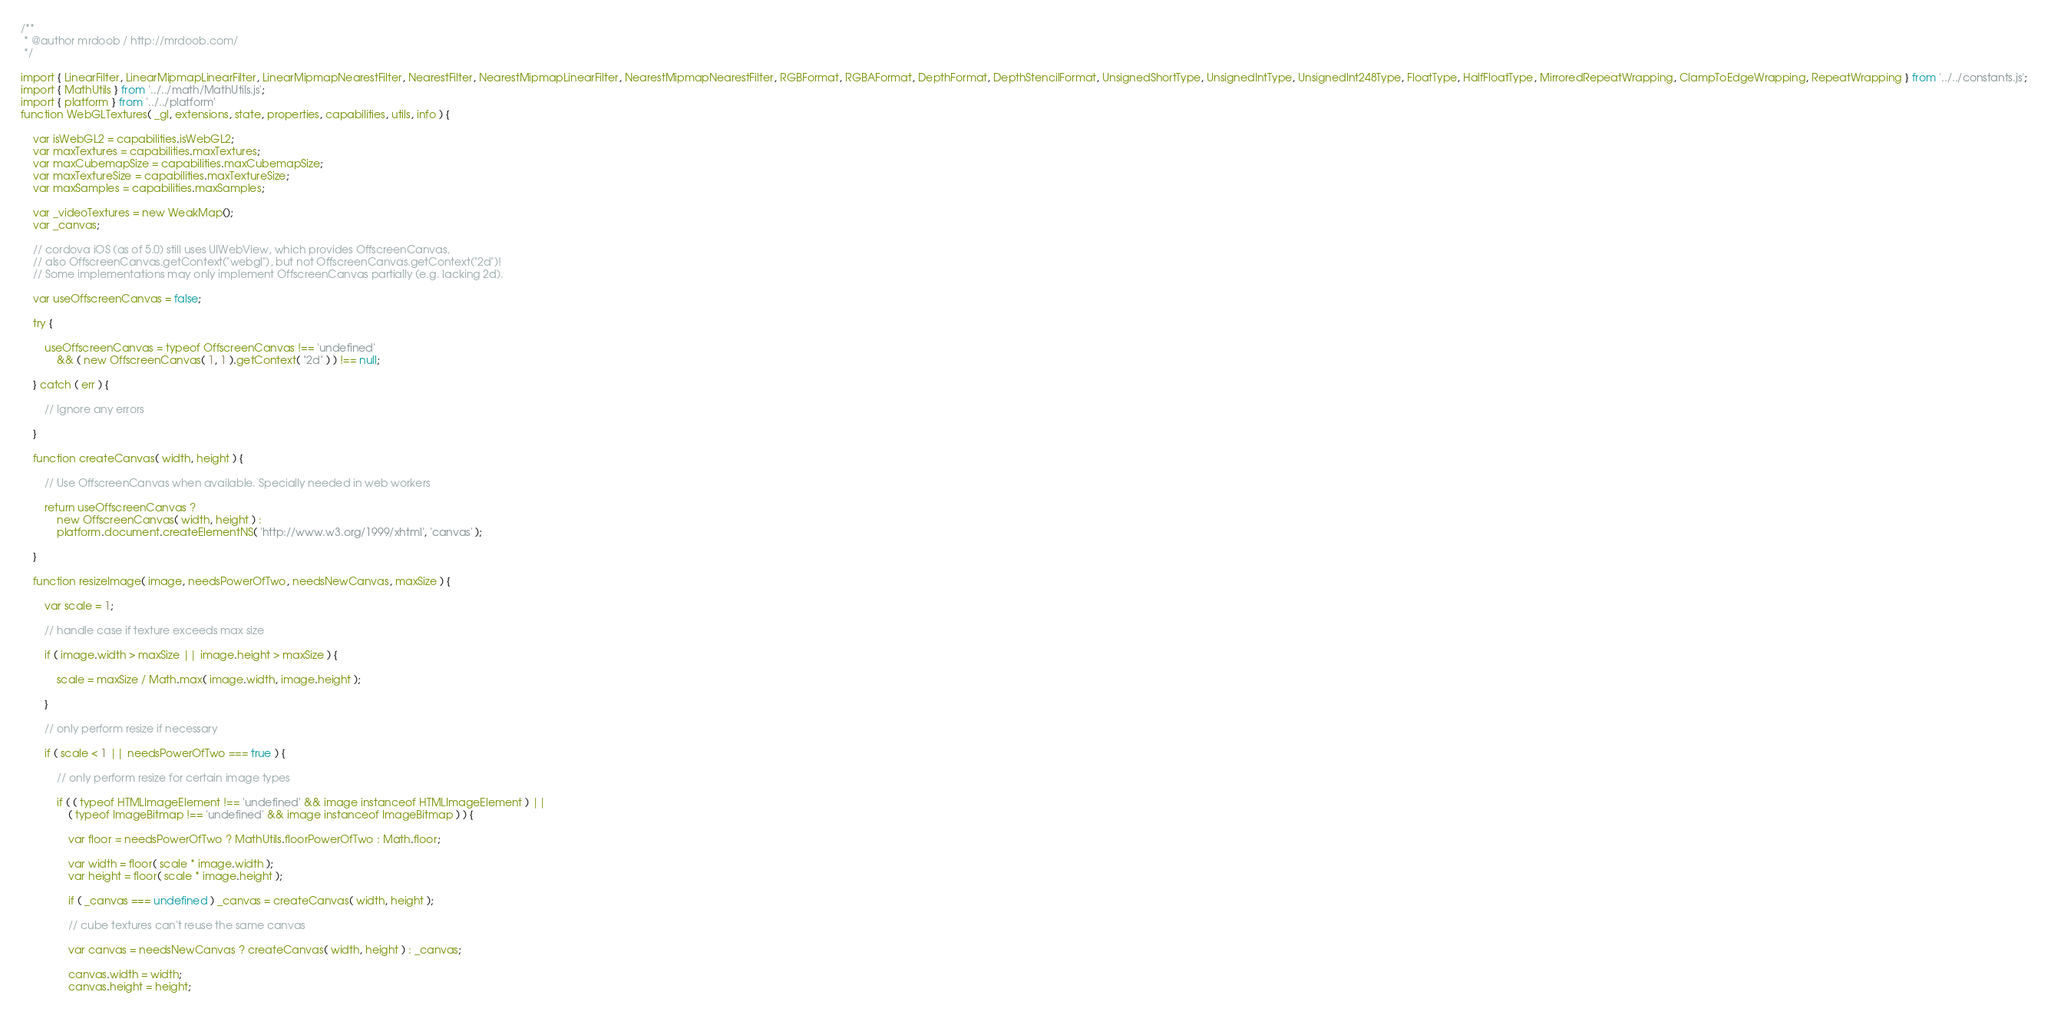Convert code to text. <code><loc_0><loc_0><loc_500><loc_500><_JavaScript_>/**
 * @author mrdoob / http://mrdoob.com/
 */

import { LinearFilter, LinearMipmapLinearFilter, LinearMipmapNearestFilter, NearestFilter, NearestMipmapLinearFilter, NearestMipmapNearestFilter, RGBFormat, RGBAFormat, DepthFormat, DepthStencilFormat, UnsignedShortType, UnsignedIntType, UnsignedInt248Type, FloatType, HalfFloatType, MirroredRepeatWrapping, ClampToEdgeWrapping, RepeatWrapping } from '../../constants.js';
import { MathUtils } from '../../math/MathUtils.js';
import { platform } from '../../platform'
function WebGLTextures( _gl, extensions, state, properties, capabilities, utils, info ) {

	var isWebGL2 = capabilities.isWebGL2;
	var maxTextures = capabilities.maxTextures;
	var maxCubemapSize = capabilities.maxCubemapSize;
	var maxTextureSize = capabilities.maxTextureSize;
	var maxSamples = capabilities.maxSamples;

	var _videoTextures = new WeakMap();
	var _canvas;

	// cordova iOS (as of 5.0) still uses UIWebView, which provides OffscreenCanvas,
	// also OffscreenCanvas.getContext("webgl"), but not OffscreenCanvas.getContext("2d")!
	// Some implementations may only implement OffscreenCanvas partially (e.g. lacking 2d).

	var useOffscreenCanvas = false;

	try {

		useOffscreenCanvas = typeof OffscreenCanvas !== 'undefined'
			&& ( new OffscreenCanvas( 1, 1 ).getContext( "2d" ) ) !== null;

	} catch ( err ) {

		// Ignore any errors

	}

	function createCanvas( width, height ) {

		// Use OffscreenCanvas when available. Specially needed in web workers

		return useOffscreenCanvas ?
			new OffscreenCanvas( width, height ) :
			platform.document.createElementNS( 'http://www.w3.org/1999/xhtml', 'canvas' );

	}

	function resizeImage( image, needsPowerOfTwo, needsNewCanvas, maxSize ) {

		var scale = 1;

		// handle case if texture exceeds max size

		if ( image.width > maxSize || image.height > maxSize ) {

			scale = maxSize / Math.max( image.width, image.height );

		}

		// only perform resize if necessary

		if ( scale < 1 || needsPowerOfTwo === true ) {

			// only perform resize for certain image types

			if ( ( typeof HTMLImageElement !== 'undefined' && image instanceof HTMLImageElement ) ||
				( typeof ImageBitmap !== 'undefined' && image instanceof ImageBitmap ) ) {

				var floor = needsPowerOfTwo ? MathUtils.floorPowerOfTwo : Math.floor;

				var width = floor( scale * image.width );
				var height = floor( scale * image.height );

				if ( _canvas === undefined ) _canvas = createCanvas( width, height );

				// cube textures can't reuse the same canvas

				var canvas = needsNewCanvas ? createCanvas( width, height ) : _canvas;

				canvas.width = width;
				canvas.height = height;
</code> 